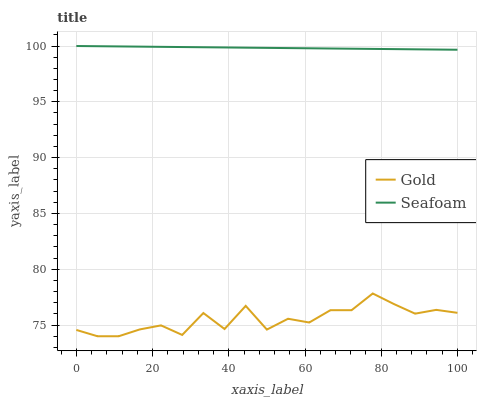Does Gold have the maximum area under the curve?
Answer yes or no. No. Is Gold the smoothest?
Answer yes or no. No. Does Gold have the highest value?
Answer yes or no. No. Is Gold less than Seafoam?
Answer yes or no. Yes. Is Seafoam greater than Gold?
Answer yes or no. Yes. Does Gold intersect Seafoam?
Answer yes or no. No. 